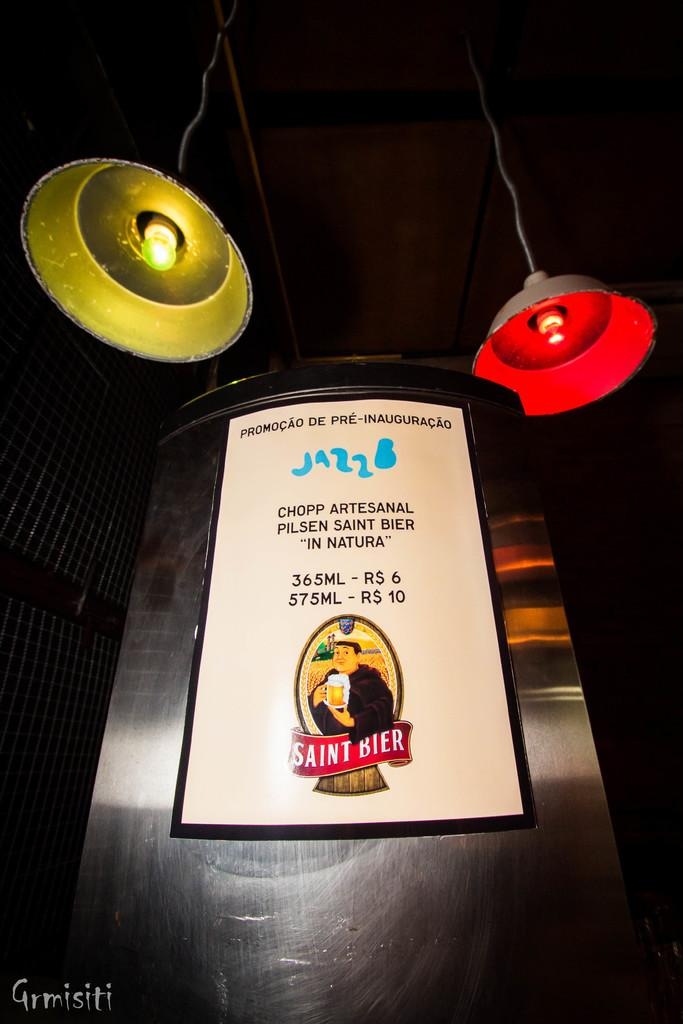<image>
Render a clear and concise summary of the photo. A billboard advertising Saint beer under two lamps 